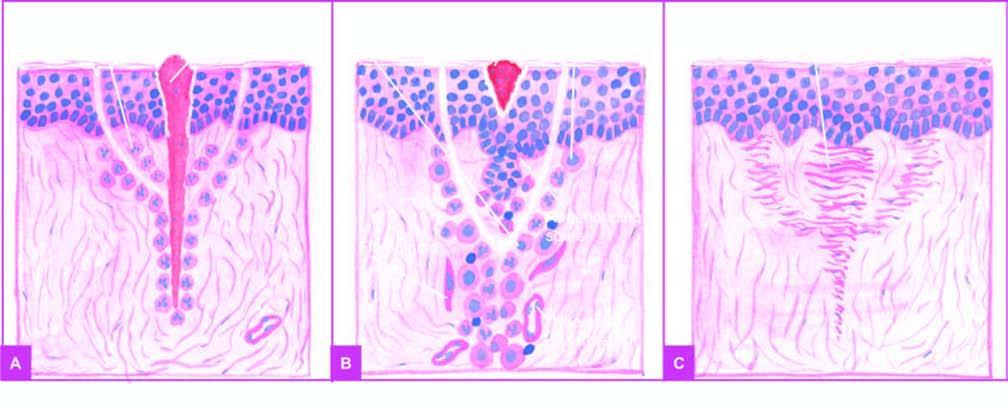does formation of granulation tissue begin from below?
Answer the question using a single word or phrase. Yes 